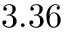Convert formula to latex. <formula><loc_0><loc_0><loc_500><loc_500>3 . 3 6</formula> 